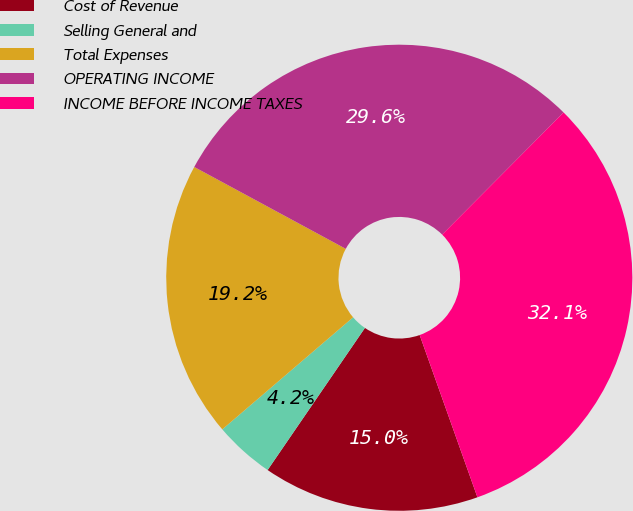Convert chart to OTSL. <chart><loc_0><loc_0><loc_500><loc_500><pie_chart><fcel>Cost of Revenue<fcel>Selling General and<fcel>Total Expenses<fcel>OPERATING INCOME<fcel>INCOME BEFORE INCOME TAXES<nl><fcel>15.0%<fcel>4.17%<fcel>19.16%<fcel>29.57%<fcel>32.11%<nl></chart> 